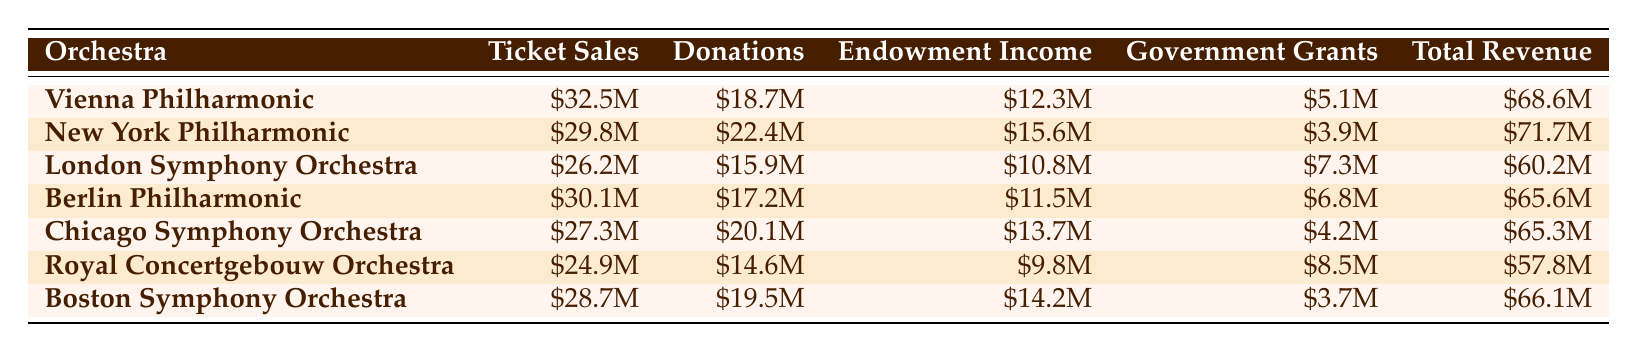What is the total revenue of the New York Philharmonic? The total revenue for the New York Philharmonic is listed directly in the table under the Total Revenue column. It shows $71.7M.
Answer: $71.7M Which orchestra has the highest ticket sales? By comparing the values in the Ticket Sales column, the Vienna Philharmonic has the highest ticket sales with $32.5M.
Answer: Vienna Philharmonic Is the total revenue for the Royal Concertgebouw Orchestra greater than $55M? The total revenue for the Royal Concertgebouw Orchestra is $57.8M, which is indeed greater than $55M.
Answer: Yes What is the average endowment income for the orchestras listed? To find the average endowment income, we add together all the values in the Endowment Income column: $12.3M + $15.6M + $10.8M + $11.5M + $13.7M + $9.8M + $14.2M = $93.9M. Then, divide by the number of orchestras (7): $93.9M / 7 = $13.41M.
Answer: $13.41M Does the Berlin Philharmonic have more government grants than the London Symphony Orchestra? The table shows that the Berlin Philharmonic has $6.8M in government grants, while the London Symphony Orchestra has $7.3M, indicating that the Berlin Philharmonic has less.
Answer: No What is the total of ticket sales for all orchestras combined? To calculate the total ticket sales, add all the values in the Ticket Sales column: $32.5M + $29.8M + $26.2M + $30.1M + $27.3M + $24.9M + $28.7M = $199.5M.
Answer: $199.5M Which orchestra has the lowest total revenue? By examining the Total Revenue column, the Royal Concertgebouw Orchestra has the lowest total revenue at $57.8M.
Answer: Royal Concertgebouw Orchestra What percentage of the total revenue does donations represent for the Boston Symphony Orchestra? The donations for the Boston Symphony Orchestra are $19.5M, and the total revenue is $66.1M. To find the percentage, use the formula (19.5M / 66.1M) * 100 = 29.5%.
Answer: 29.5% 